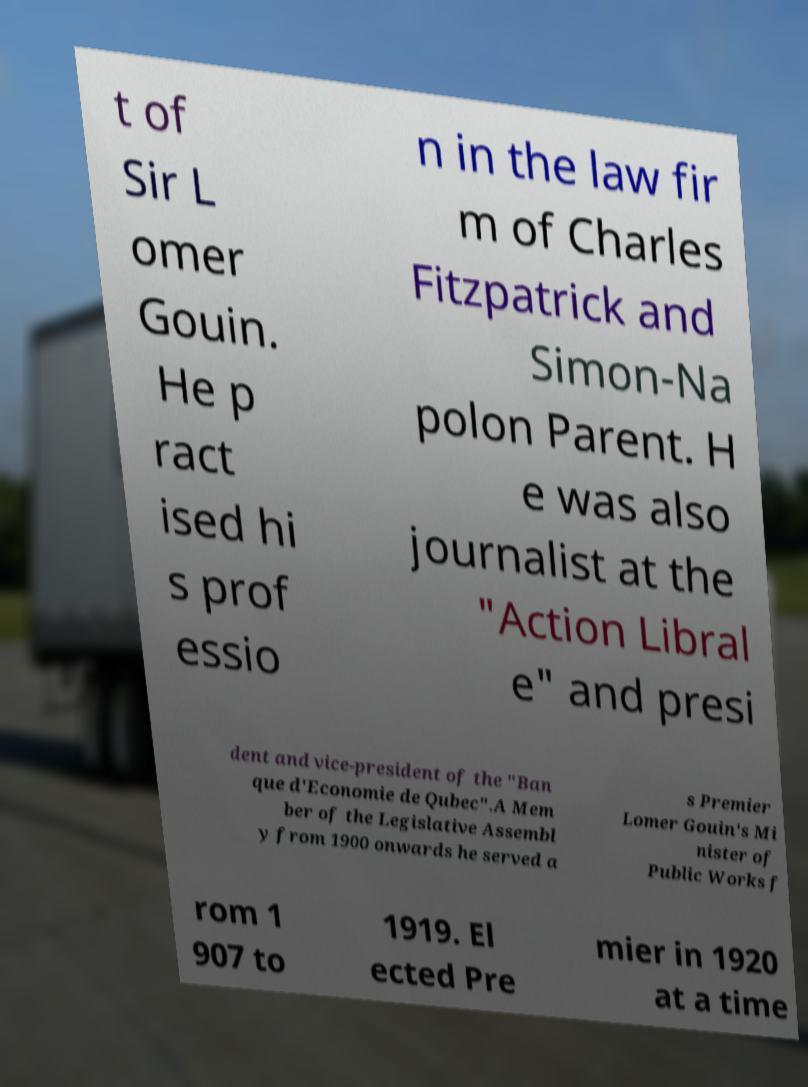For documentation purposes, I need the text within this image transcribed. Could you provide that? t of Sir L omer Gouin. He p ract ised hi s prof essio n in the law fir m of Charles Fitzpatrick and Simon-Na polon Parent. H e was also journalist at the "Action Libral e" and presi dent and vice-president of the "Ban que d'Economie de Qubec".A Mem ber of the Legislative Assembl y from 1900 onwards he served a s Premier Lomer Gouin's Mi nister of Public Works f rom 1 907 to 1919. El ected Pre mier in 1920 at a time 